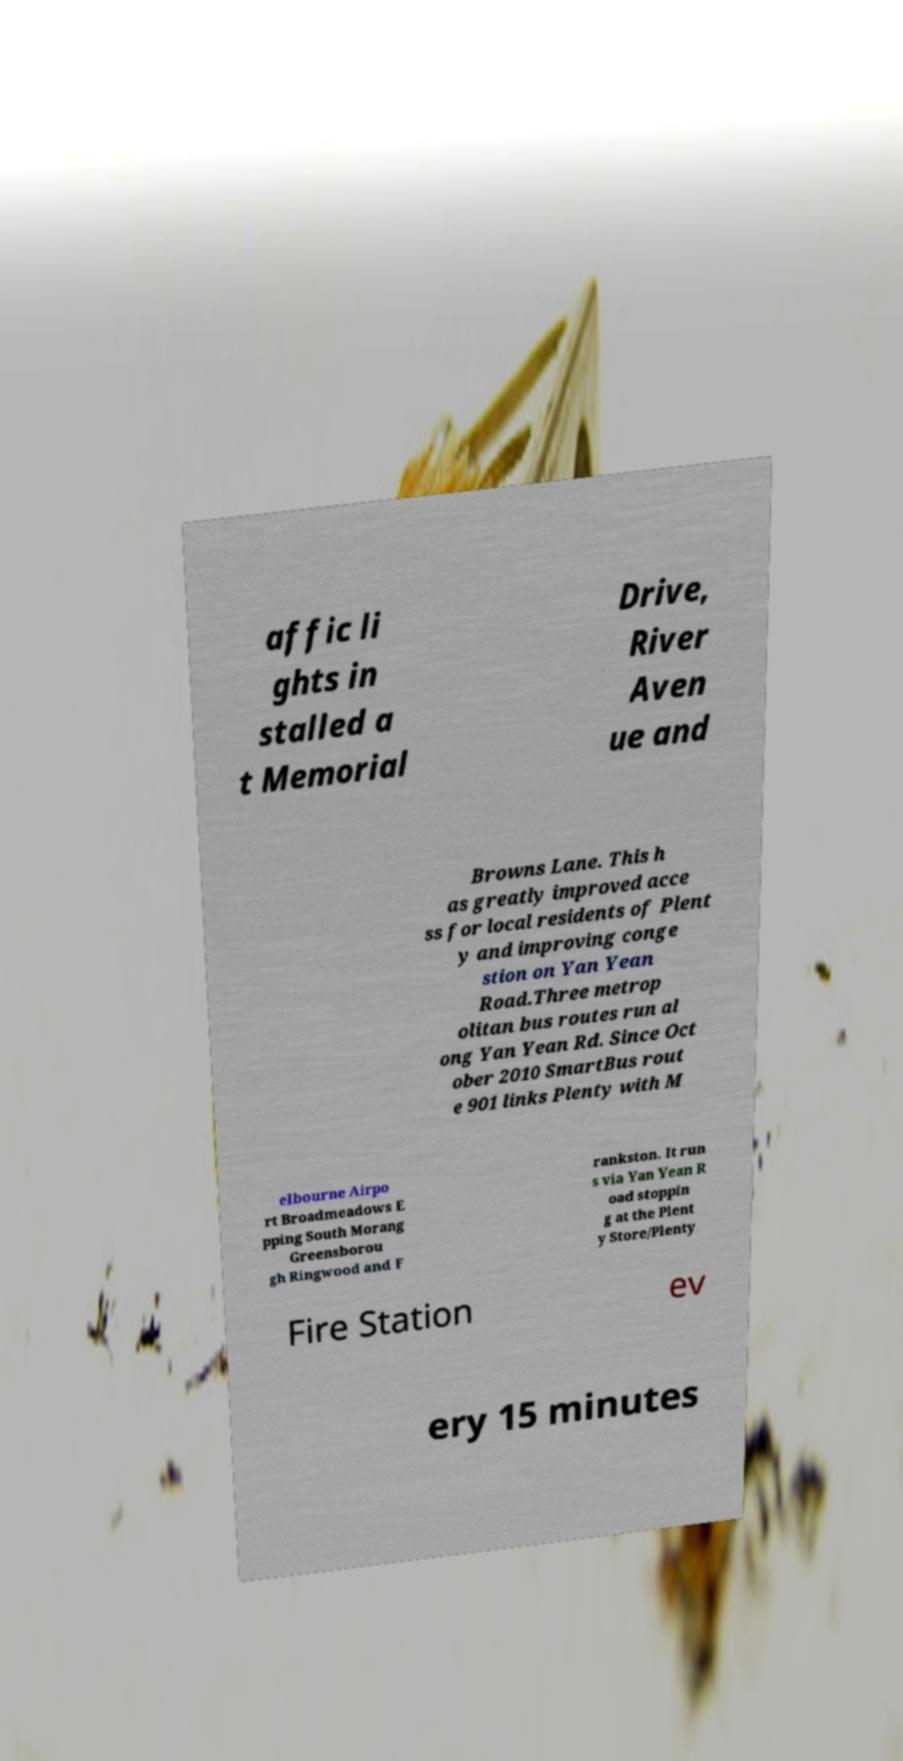Could you extract and type out the text from this image? affic li ghts in stalled a t Memorial Drive, River Aven ue and Browns Lane. This h as greatly improved acce ss for local residents of Plent y and improving conge stion on Yan Yean Road.Three metrop olitan bus routes run al ong Yan Yean Rd. Since Oct ober 2010 SmartBus rout e 901 links Plenty with M elbourne Airpo rt Broadmeadows E pping South Morang Greensborou gh Ringwood and F rankston. It run s via Yan Yean R oad stoppin g at the Plent y Store/Plenty Fire Station ev ery 15 minutes 